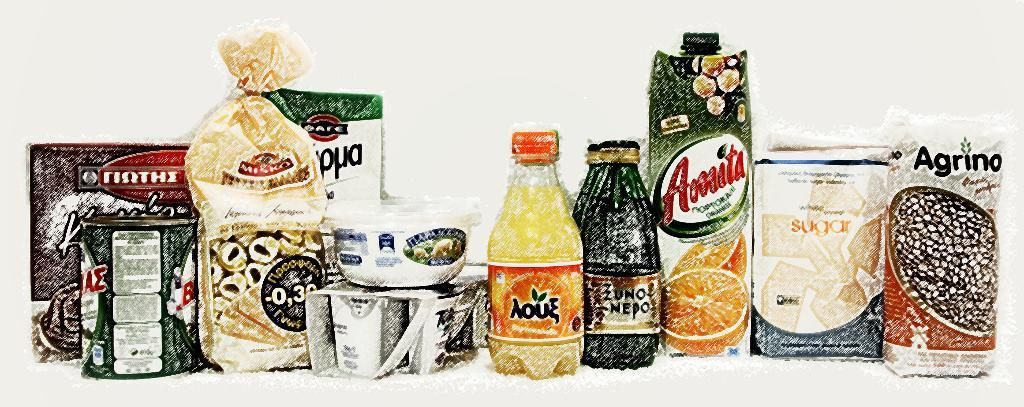<image>
Write a terse but informative summary of the picture. Groceries with Greek writing on them include Amita and Agrino 